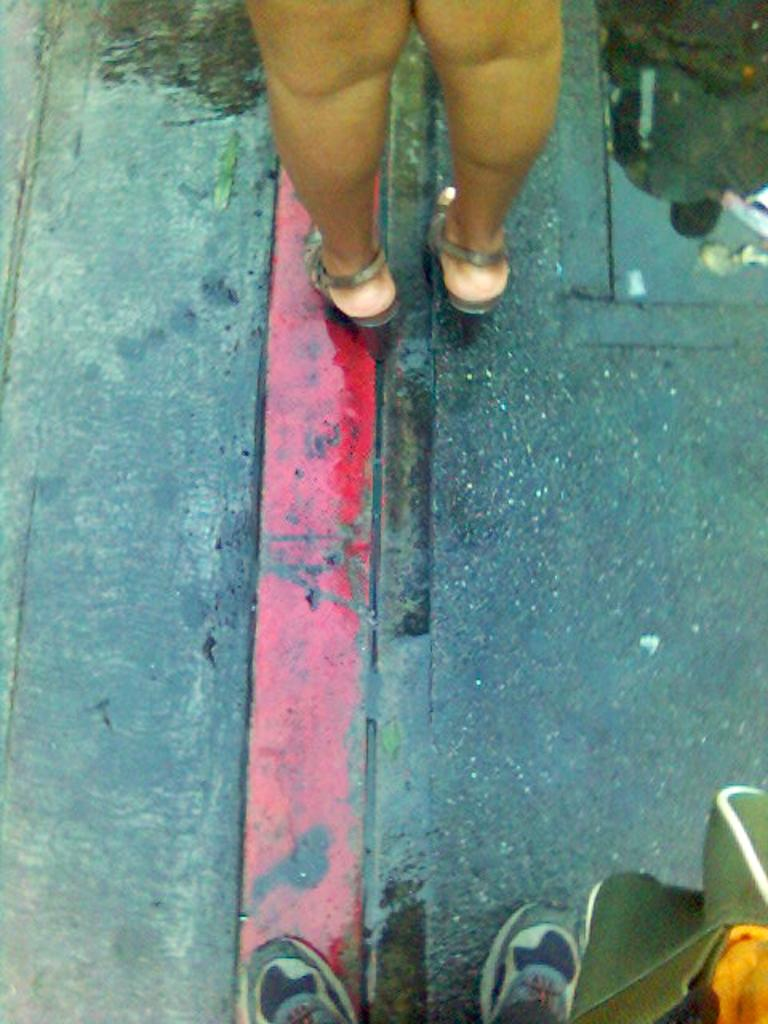What can be seen in the image related to people? There are legs of people visible in the image. Where are the legs located? The legs are on a road. What else is visible on the road in the image? There is a reflection of a person on the road in the image. What type of underwear is the person wearing in the image? There is no information about the person's underwear in the image, as only their legs are visible. 